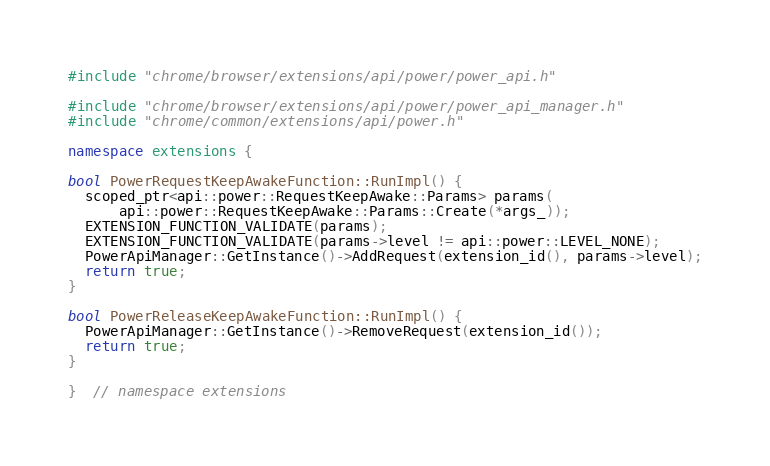Convert code to text. <code><loc_0><loc_0><loc_500><loc_500><_C++_>#include "chrome/browser/extensions/api/power/power_api.h"

#include "chrome/browser/extensions/api/power/power_api_manager.h"
#include "chrome/common/extensions/api/power.h"

namespace extensions {

bool PowerRequestKeepAwakeFunction::RunImpl() {
  scoped_ptr<api::power::RequestKeepAwake::Params> params(
      api::power::RequestKeepAwake::Params::Create(*args_));
  EXTENSION_FUNCTION_VALIDATE(params);
  EXTENSION_FUNCTION_VALIDATE(params->level != api::power::LEVEL_NONE);
  PowerApiManager::GetInstance()->AddRequest(extension_id(), params->level);
  return true;
}

bool PowerReleaseKeepAwakeFunction::RunImpl() {
  PowerApiManager::GetInstance()->RemoveRequest(extension_id());
  return true;
}

}  // namespace extensions
</code> 